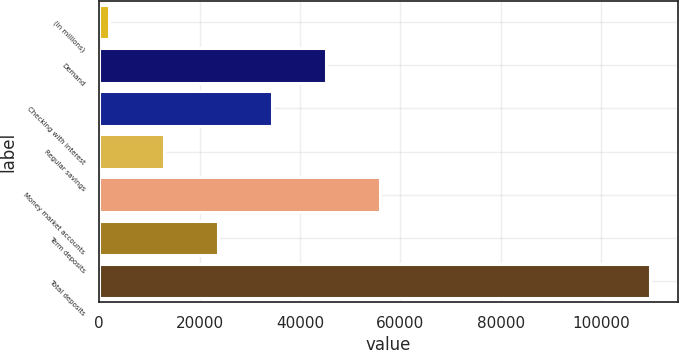Convert chart. <chart><loc_0><loc_0><loc_500><loc_500><bar_chart><fcel>(in millions)<fcel>Demand<fcel>Checking with interest<fcel>Regular savings<fcel>Money market accounts<fcel>Term deposits<fcel>Total deposits<nl><fcel>2016<fcel>45131.2<fcel>34352.4<fcel>12794.8<fcel>55910<fcel>23573.6<fcel>109804<nl></chart> 